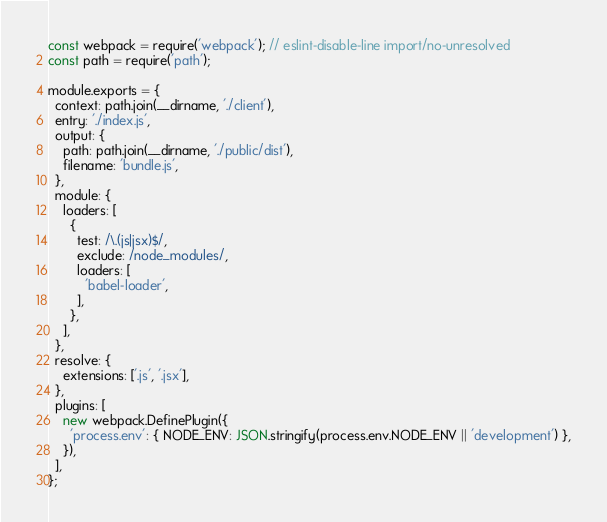<code> <loc_0><loc_0><loc_500><loc_500><_JavaScript_>
const webpack = require('webpack'); // eslint-disable-line import/no-unresolved
const path = require('path');

module.exports = {
  context: path.join(__dirname, './client'),
  entry: './index.js',
  output: {
    path: path.join(__dirname, './public/dist'),
    filename: 'bundle.js',
  },
  module: {
    loaders: [
      {
        test: /\.(js|jsx)$/,
        exclude: /node_modules/,
        loaders: [
          'babel-loader',
        ],
      },
    ],
  },
  resolve: {
    extensions: ['.js', '.jsx'],
  },
  plugins: [
    new webpack.DefinePlugin({
      'process.env': { NODE_ENV: JSON.stringify(process.env.NODE_ENV || 'development') },
    }),
  ],
};
</code> 